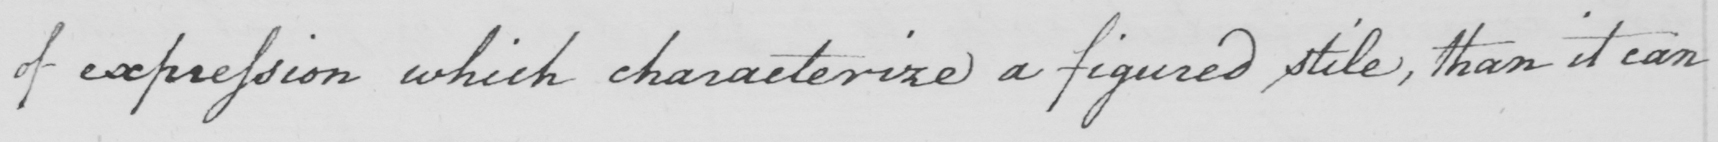Transcribe the text shown in this historical manuscript line. of expression which characterize a figured stile , than it can 